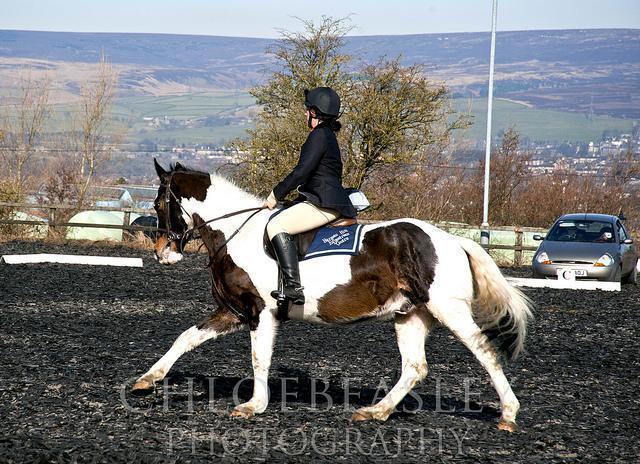What is on top of the horse?
From the following four choices, select the correct answer to address the question.
Options: Old man, cat, girl, bird. Girl. 